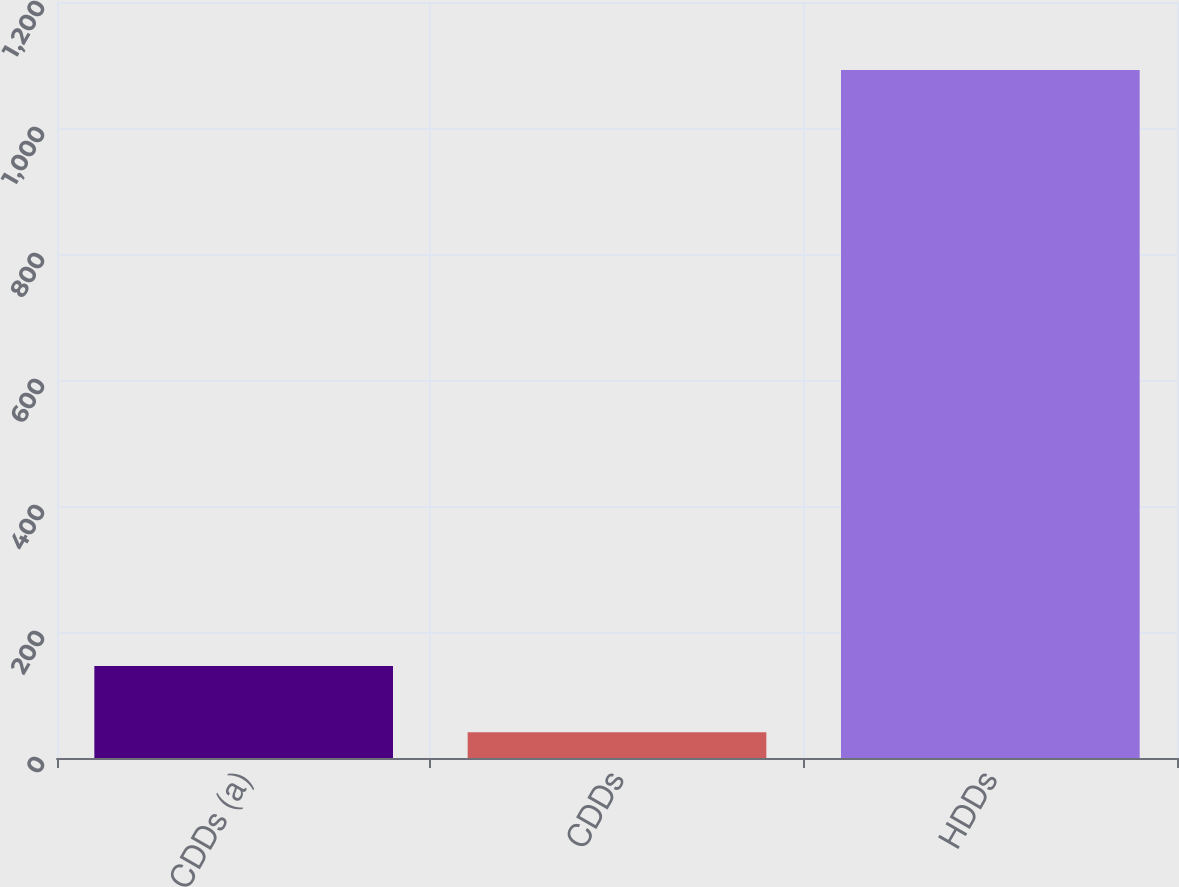<chart> <loc_0><loc_0><loc_500><loc_500><bar_chart><fcel>CDDs (a)<fcel>CDDs<fcel>HDDs<nl><fcel>146.1<fcel>41<fcel>1092<nl></chart> 